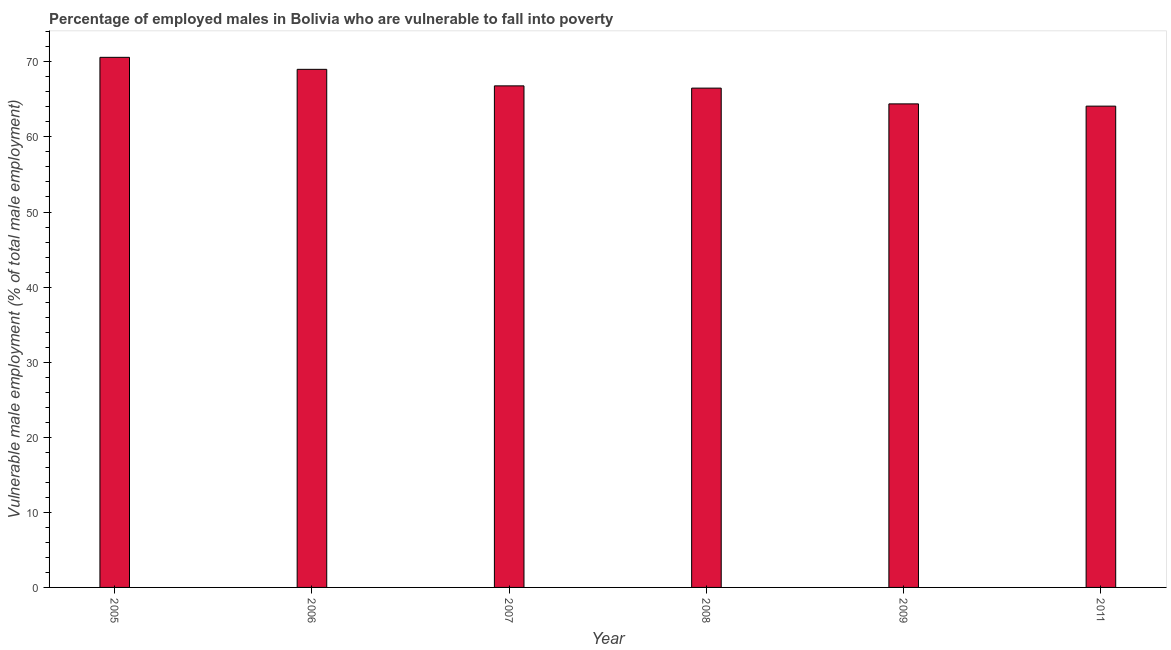Does the graph contain any zero values?
Give a very brief answer. No. Does the graph contain grids?
Provide a succinct answer. No. What is the title of the graph?
Provide a succinct answer. Percentage of employed males in Bolivia who are vulnerable to fall into poverty. What is the label or title of the Y-axis?
Make the answer very short. Vulnerable male employment (% of total male employment). What is the percentage of employed males who are vulnerable to fall into poverty in 2005?
Offer a very short reply. 70.6. Across all years, what is the maximum percentage of employed males who are vulnerable to fall into poverty?
Offer a terse response. 70.6. Across all years, what is the minimum percentage of employed males who are vulnerable to fall into poverty?
Make the answer very short. 64.1. In which year was the percentage of employed males who are vulnerable to fall into poverty maximum?
Provide a succinct answer. 2005. What is the sum of the percentage of employed males who are vulnerable to fall into poverty?
Give a very brief answer. 401.4. What is the difference between the percentage of employed males who are vulnerable to fall into poverty in 2006 and 2008?
Your response must be concise. 2.5. What is the average percentage of employed males who are vulnerable to fall into poverty per year?
Keep it short and to the point. 66.9. What is the median percentage of employed males who are vulnerable to fall into poverty?
Ensure brevity in your answer.  66.65. In how many years, is the percentage of employed males who are vulnerable to fall into poverty greater than 54 %?
Your answer should be compact. 6. Do a majority of the years between 2008 and 2011 (inclusive) have percentage of employed males who are vulnerable to fall into poverty greater than 72 %?
Offer a terse response. No. What is the ratio of the percentage of employed males who are vulnerable to fall into poverty in 2006 to that in 2007?
Offer a very short reply. 1.03. What is the difference between the highest and the second highest percentage of employed males who are vulnerable to fall into poverty?
Make the answer very short. 1.6. What is the difference between the highest and the lowest percentage of employed males who are vulnerable to fall into poverty?
Make the answer very short. 6.5. How many bars are there?
Provide a succinct answer. 6. Are all the bars in the graph horizontal?
Ensure brevity in your answer.  No. How many years are there in the graph?
Your answer should be compact. 6. What is the difference between two consecutive major ticks on the Y-axis?
Offer a very short reply. 10. Are the values on the major ticks of Y-axis written in scientific E-notation?
Make the answer very short. No. What is the Vulnerable male employment (% of total male employment) of 2005?
Offer a very short reply. 70.6. What is the Vulnerable male employment (% of total male employment) in 2007?
Your answer should be compact. 66.8. What is the Vulnerable male employment (% of total male employment) in 2008?
Your response must be concise. 66.5. What is the Vulnerable male employment (% of total male employment) of 2009?
Provide a short and direct response. 64.4. What is the Vulnerable male employment (% of total male employment) of 2011?
Your answer should be very brief. 64.1. What is the difference between the Vulnerable male employment (% of total male employment) in 2005 and 2006?
Keep it short and to the point. 1.6. What is the difference between the Vulnerable male employment (% of total male employment) in 2005 and 2008?
Offer a very short reply. 4.1. What is the difference between the Vulnerable male employment (% of total male employment) in 2006 and 2007?
Your response must be concise. 2.2. What is the difference between the Vulnerable male employment (% of total male employment) in 2006 and 2009?
Your answer should be compact. 4.6. What is the difference between the Vulnerable male employment (% of total male employment) in 2006 and 2011?
Make the answer very short. 4.9. What is the difference between the Vulnerable male employment (% of total male employment) in 2007 and 2009?
Your answer should be compact. 2.4. What is the difference between the Vulnerable male employment (% of total male employment) in 2007 and 2011?
Offer a terse response. 2.7. What is the difference between the Vulnerable male employment (% of total male employment) in 2009 and 2011?
Offer a terse response. 0.3. What is the ratio of the Vulnerable male employment (% of total male employment) in 2005 to that in 2006?
Provide a succinct answer. 1.02. What is the ratio of the Vulnerable male employment (% of total male employment) in 2005 to that in 2007?
Keep it short and to the point. 1.06. What is the ratio of the Vulnerable male employment (% of total male employment) in 2005 to that in 2008?
Offer a very short reply. 1.06. What is the ratio of the Vulnerable male employment (% of total male employment) in 2005 to that in 2009?
Give a very brief answer. 1.1. What is the ratio of the Vulnerable male employment (% of total male employment) in 2005 to that in 2011?
Provide a short and direct response. 1.1. What is the ratio of the Vulnerable male employment (% of total male employment) in 2006 to that in 2007?
Your response must be concise. 1.03. What is the ratio of the Vulnerable male employment (% of total male employment) in 2006 to that in 2008?
Make the answer very short. 1.04. What is the ratio of the Vulnerable male employment (% of total male employment) in 2006 to that in 2009?
Offer a very short reply. 1.07. What is the ratio of the Vulnerable male employment (% of total male employment) in 2006 to that in 2011?
Keep it short and to the point. 1.08. What is the ratio of the Vulnerable male employment (% of total male employment) in 2007 to that in 2008?
Ensure brevity in your answer.  1. What is the ratio of the Vulnerable male employment (% of total male employment) in 2007 to that in 2011?
Your answer should be compact. 1.04. What is the ratio of the Vulnerable male employment (% of total male employment) in 2008 to that in 2009?
Offer a very short reply. 1.03. What is the ratio of the Vulnerable male employment (% of total male employment) in 2008 to that in 2011?
Provide a short and direct response. 1.04. What is the ratio of the Vulnerable male employment (% of total male employment) in 2009 to that in 2011?
Offer a very short reply. 1. 